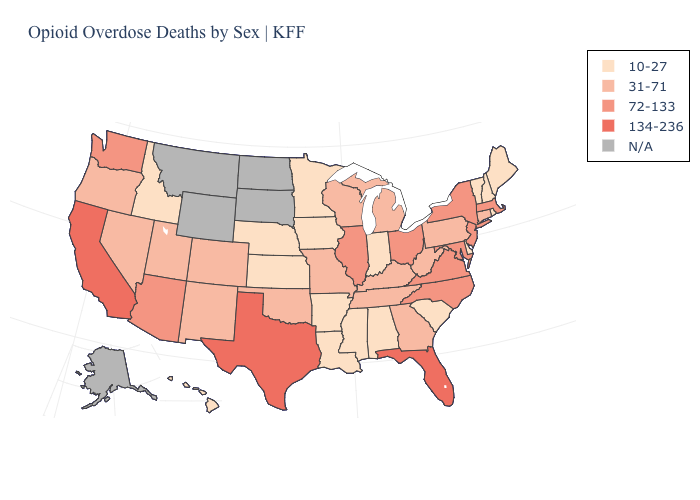Among the states that border Rhode Island , which have the highest value?
Concise answer only. Massachusetts. Name the states that have a value in the range 10-27?
Keep it brief. Alabama, Arkansas, Delaware, Hawaii, Idaho, Indiana, Iowa, Kansas, Louisiana, Maine, Minnesota, Mississippi, Nebraska, New Hampshire, Rhode Island, South Carolina, Vermont. Name the states that have a value in the range 134-236?
Give a very brief answer. California, Florida, Texas. Name the states that have a value in the range 72-133?
Short answer required. Arizona, Illinois, Maryland, Massachusetts, New Jersey, New York, North Carolina, Ohio, Virginia, Washington. What is the highest value in states that border New Mexico?
Quick response, please. 134-236. Does Oregon have the highest value in the West?
Concise answer only. No. Name the states that have a value in the range 134-236?
Answer briefly. California, Florida, Texas. What is the value of North Dakota?
Quick response, please. N/A. Does California have the highest value in the USA?
Quick response, please. Yes. Does the map have missing data?
Quick response, please. Yes. What is the value of New Hampshire?
Give a very brief answer. 10-27. What is the highest value in the Northeast ?
Quick response, please. 72-133. How many symbols are there in the legend?
Give a very brief answer. 5. Name the states that have a value in the range 134-236?
Be succinct. California, Florida, Texas. Name the states that have a value in the range N/A?
Answer briefly. Alaska, Montana, North Dakota, South Dakota, Wyoming. 